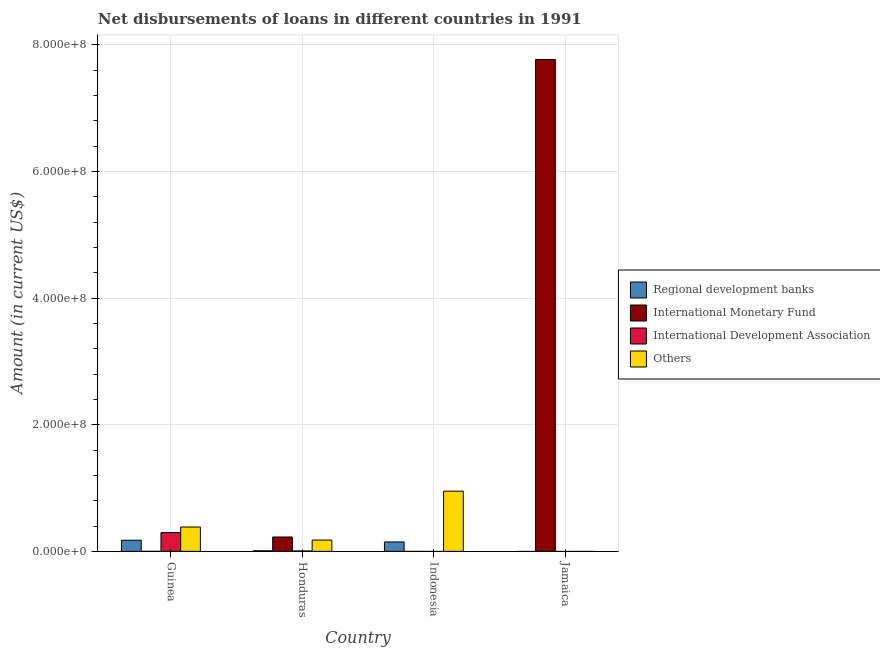How many different coloured bars are there?
Provide a short and direct response. 4. What is the label of the 3rd group of bars from the left?
Provide a short and direct response. Indonesia. In how many cases, is the number of bars for a given country not equal to the number of legend labels?
Offer a terse response. 3. Across all countries, what is the maximum amount of loan disimbursed by international development association?
Your answer should be compact. 2.96e+07. In which country was the amount of loan disimbursed by international development association maximum?
Your response must be concise. Guinea. What is the total amount of loan disimbursed by regional development banks in the graph?
Your answer should be very brief. 3.34e+07. What is the difference between the amount of loan disimbursed by other organisations in Honduras and that in Indonesia?
Offer a terse response. -7.73e+07. What is the average amount of loan disimbursed by regional development banks per country?
Keep it short and to the point. 8.35e+06. What is the difference between the amount of loan disimbursed by regional development banks and amount of loan disimbursed by other organisations in Guinea?
Keep it short and to the point. -2.08e+07. What is the ratio of the amount of loan disimbursed by other organisations in Honduras to that in Indonesia?
Ensure brevity in your answer.  0.19. What is the difference between the highest and the second highest amount of loan disimbursed by regional development banks?
Offer a terse response. 2.73e+06. What is the difference between the highest and the lowest amount of loan disimbursed by regional development banks?
Ensure brevity in your answer.  1.76e+07. Is it the case that in every country, the sum of the amount of loan disimbursed by other organisations and amount of loan disimbursed by regional development banks is greater than the sum of amount of loan disimbursed by international monetary fund and amount of loan disimbursed by international development association?
Provide a succinct answer. No. Is it the case that in every country, the sum of the amount of loan disimbursed by regional development banks and amount of loan disimbursed by international monetary fund is greater than the amount of loan disimbursed by international development association?
Provide a short and direct response. No. How many bars are there?
Provide a short and direct response. 10. How many countries are there in the graph?
Keep it short and to the point. 4. Does the graph contain any zero values?
Make the answer very short. Yes. Does the graph contain grids?
Ensure brevity in your answer.  Yes. How many legend labels are there?
Offer a very short reply. 4. What is the title of the graph?
Your answer should be very brief. Net disbursements of loans in different countries in 1991. What is the label or title of the X-axis?
Keep it short and to the point. Country. What is the Amount (in current US$) of Regional development banks in Guinea?
Your answer should be very brief. 1.76e+07. What is the Amount (in current US$) in International Development Association in Guinea?
Provide a short and direct response. 2.96e+07. What is the Amount (in current US$) of Others in Guinea?
Provide a succinct answer. 3.84e+07. What is the Amount (in current US$) in Regional development banks in Honduras?
Offer a terse response. 9.04e+05. What is the Amount (in current US$) in International Monetary Fund in Honduras?
Your answer should be very brief. 2.27e+07. What is the Amount (in current US$) in International Development Association in Honduras?
Your answer should be very brief. 6.17e+05. What is the Amount (in current US$) in Others in Honduras?
Your answer should be compact. 1.78e+07. What is the Amount (in current US$) of Regional development banks in Indonesia?
Offer a very short reply. 1.49e+07. What is the Amount (in current US$) of Others in Indonesia?
Offer a terse response. 9.51e+07. What is the Amount (in current US$) of Regional development banks in Jamaica?
Keep it short and to the point. 0. What is the Amount (in current US$) of International Monetary Fund in Jamaica?
Keep it short and to the point. 7.77e+08. What is the Amount (in current US$) in International Development Association in Jamaica?
Provide a succinct answer. 0. Across all countries, what is the maximum Amount (in current US$) of Regional development banks?
Your response must be concise. 1.76e+07. Across all countries, what is the maximum Amount (in current US$) in International Monetary Fund?
Your answer should be very brief. 7.77e+08. Across all countries, what is the maximum Amount (in current US$) in International Development Association?
Give a very brief answer. 2.96e+07. Across all countries, what is the maximum Amount (in current US$) in Others?
Keep it short and to the point. 9.51e+07. Across all countries, what is the minimum Amount (in current US$) in Regional development banks?
Ensure brevity in your answer.  0. Across all countries, what is the minimum Amount (in current US$) in International Monetary Fund?
Keep it short and to the point. 0. Across all countries, what is the minimum Amount (in current US$) in Others?
Your answer should be compact. 0. What is the total Amount (in current US$) in Regional development banks in the graph?
Give a very brief answer. 3.34e+07. What is the total Amount (in current US$) of International Monetary Fund in the graph?
Provide a succinct answer. 7.99e+08. What is the total Amount (in current US$) of International Development Association in the graph?
Offer a very short reply. 3.02e+07. What is the total Amount (in current US$) in Others in the graph?
Provide a short and direct response. 1.51e+08. What is the difference between the Amount (in current US$) of Regional development banks in Guinea and that in Honduras?
Your response must be concise. 1.67e+07. What is the difference between the Amount (in current US$) of International Development Association in Guinea and that in Honduras?
Make the answer very short. 2.90e+07. What is the difference between the Amount (in current US$) of Others in Guinea and that in Honduras?
Your answer should be compact. 2.06e+07. What is the difference between the Amount (in current US$) in Regional development banks in Guinea and that in Indonesia?
Keep it short and to the point. 2.73e+06. What is the difference between the Amount (in current US$) in Others in Guinea and that in Indonesia?
Your response must be concise. -5.67e+07. What is the difference between the Amount (in current US$) of Regional development banks in Honduras and that in Indonesia?
Keep it short and to the point. -1.40e+07. What is the difference between the Amount (in current US$) in Others in Honduras and that in Indonesia?
Your response must be concise. -7.73e+07. What is the difference between the Amount (in current US$) in International Monetary Fund in Honduras and that in Jamaica?
Make the answer very short. -7.54e+08. What is the difference between the Amount (in current US$) in Regional development banks in Guinea and the Amount (in current US$) in International Monetary Fund in Honduras?
Your answer should be compact. -5.09e+06. What is the difference between the Amount (in current US$) of Regional development banks in Guinea and the Amount (in current US$) of International Development Association in Honduras?
Provide a succinct answer. 1.70e+07. What is the difference between the Amount (in current US$) of Regional development banks in Guinea and the Amount (in current US$) of Others in Honduras?
Keep it short and to the point. -2.24e+05. What is the difference between the Amount (in current US$) of International Development Association in Guinea and the Amount (in current US$) of Others in Honduras?
Your answer should be very brief. 1.18e+07. What is the difference between the Amount (in current US$) of Regional development banks in Guinea and the Amount (in current US$) of Others in Indonesia?
Ensure brevity in your answer.  -7.75e+07. What is the difference between the Amount (in current US$) of International Development Association in Guinea and the Amount (in current US$) of Others in Indonesia?
Ensure brevity in your answer.  -6.55e+07. What is the difference between the Amount (in current US$) of Regional development banks in Guinea and the Amount (in current US$) of International Monetary Fund in Jamaica?
Offer a very short reply. -7.59e+08. What is the difference between the Amount (in current US$) of Regional development banks in Honduras and the Amount (in current US$) of Others in Indonesia?
Your response must be concise. -9.42e+07. What is the difference between the Amount (in current US$) in International Monetary Fund in Honduras and the Amount (in current US$) in Others in Indonesia?
Offer a very short reply. -7.24e+07. What is the difference between the Amount (in current US$) of International Development Association in Honduras and the Amount (in current US$) of Others in Indonesia?
Your answer should be compact. -9.45e+07. What is the difference between the Amount (in current US$) of Regional development banks in Honduras and the Amount (in current US$) of International Monetary Fund in Jamaica?
Your response must be concise. -7.76e+08. What is the difference between the Amount (in current US$) of Regional development banks in Indonesia and the Amount (in current US$) of International Monetary Fund in Jamaica?
Your response must be concise. -7.62e+08. What is the average Amount (in current US$) of Regional development banks per country?
Keep it short and to the point. 8.35e+06. What is the average Amount (in current US$) of International Monetary Fund per country?
Your answer should be compact. 2.00e+08. What is the average Amount (in current US$) in International Development Association per country?
Offer a terse response. 7.56e+06. What is the average Amount (in current US$) in Others per country?
Your answer should be very brief. 3.78e+07. What is the difference between the Amount (in current US$) of Regional development banks and Amount (in current US$) of International Development Association in Guinea?
Your response must be concise. -1.20e+07. What is the difference between the Amount (in current US$) of Regional development banks and Amount (in current US$) of Others in Guinea?
Provide a succinct answer. -2.08e+07. What is the difference between the Amount (in current US$) of International Development Association and Amount (in current US$) of Others in Guinea?
Your response must be concise. -8.81e+06. What is the difference between the Amount (in current US$) of Regional development banks and Amount (in current US$) of International Monetary Fund in Honduras?
Ensure brevity in your answer.  -2.18e+07. What is the difference between the Amount (in current US$) of Regional development banks and Amount (in current US$) of International Development Association in Honduras?
Offer a very short reply. 2.87e+05. What is the difference between the Amount (in current US$) of Regional development banks and Amount (in current US$) of Others in Honduras?
Make the answer very short. -1.69e+07. What is the difference between the Amount (in current US$) of International Monetary Fund and Amount (in current US$) of International Development Association in Honduras?
Your answer should be very brief. 2.21e+07. What is the difference between the Amount (in current US$) in International Monetary Fund and Amount (in current US$) in Others in Honduras?
Offer a very short reply. 4.87e+06. What is the difference between the Amount (in current US$) in International Development Association and Amount (in current US$) in Others in Honduras?
Provide a short and direct response. -1.72e+07. What is the difference between the Amount (in current US$) of Regional development banks and Amount (in current US$) of Others in Indonesia?
Provide a short and direct response. -8.02e+07. What is the ratio of the Amount (in current US$) in Regional development banks in Guinea to that in Honduras?
Provide a short and direct response. 19.48. What is the ratio of the Amount (in current US$) of International Development Association in Guinea to that in Honduras?
Provide a succinct answer. 48.03. What is the ratio of the Amount (in current US$) of Others in Guinea to that in Honduras?
Keep it short and to the point. 2.16. What is the ratio of the Amount (in current US$) in Regional development banks in Guinea to that in Indonesia?
Give a very brief answer. 1.18. What is the ratio of the Amount (in current US$) in Others in Guinea to that in Indonesia?
Make the answer very short. 0.4. What is the ratio of the Amount (in current US$) of Regional development banks in Honduras to that in Indonesia?
Your answer should be compact. 0.06. What is the ratio of the Amount (in current US$) in Others in Honduras to that in Indonesia?
Your response must be concise. 0.19. What is the ratio of the Amount (in current US$) in International Monetary Fund in Honduras to that in Jamaica?
Offer a terse response. 0.03. What is the difference between the highest and the second highest Amount (in current US$) in Regional development banks?
Keep it short and to the point. 2.73e+06. What is the difference between the highest and the second highest Amount (in current US$) of Others?
Make the answer very short. 5.67e+07. What is the difference between the highest and the lowest Amount (in current US$) in Regional development banks?
Offer a terse response. 1.76e+07. What is the difference between the highest and the lowest Amount (in current US$) of International Monetary Fund?
Give a very brief answer. 7.77e+08. What is the difference between the highest and the lowest Amount (in current US$) of International Development Association?
Your response must be concise. 2.96e+07. What is the difference between the highest and the lowest Amount (in current US$) of Others?
Give a very brief answer. 9.51e+07. 